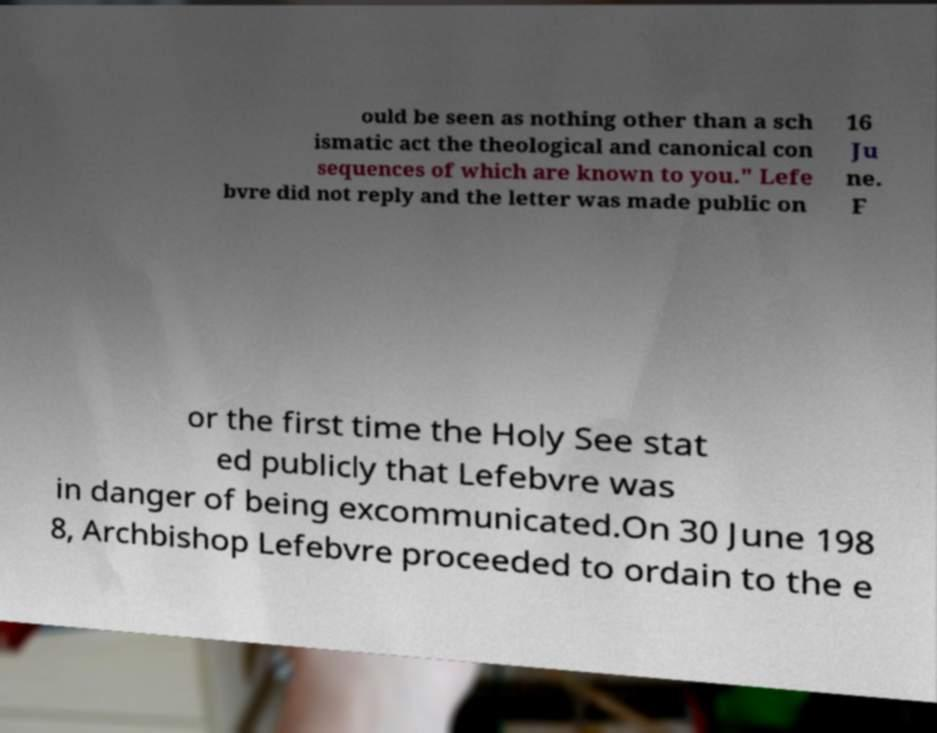For documentation purposes, I need the text within this image transcribed. Could you provide that? ould be seen as nothing other than a sch ismatic act the theological and canonical con sequences of which are known to you." Lefe bvre did not reply and the letter was made public on 16 Ju ne. F or the first time the Holy See stat ed publicly that Lefebvre was in danger of being excommunicated.On 30 June 198 8, Archbishop Lefebvre proceeded to ordain to the e 